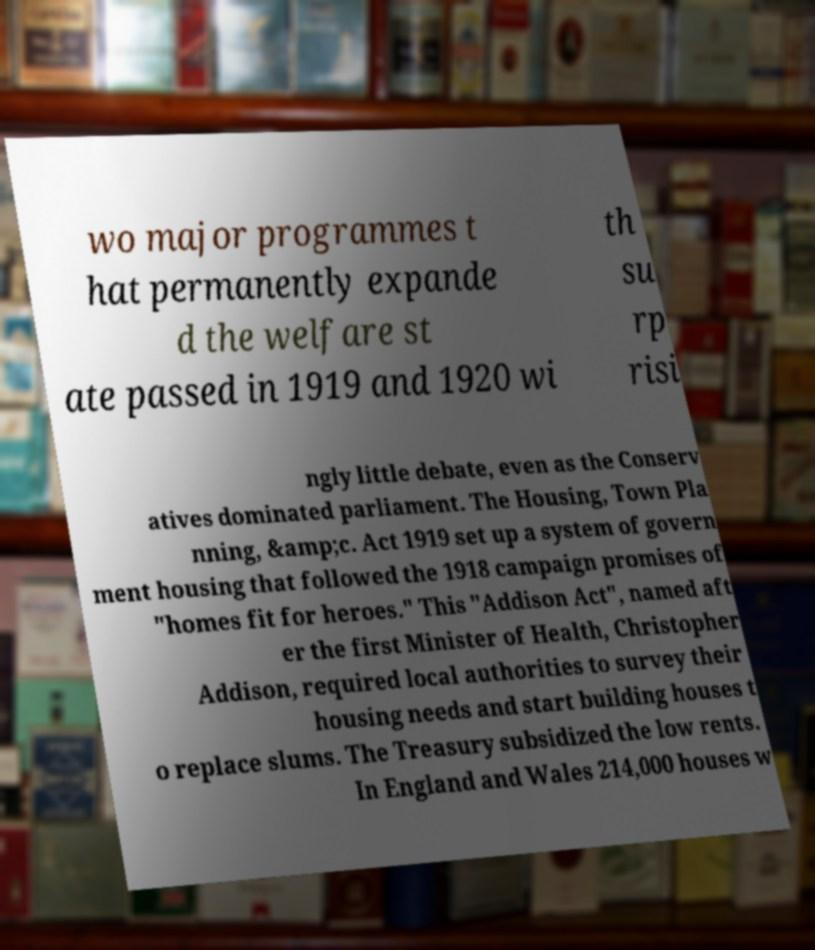There's text embedded in this image that I need extracted. Can you transcribe it verbatim? wo major programmes t hat permanently expande d the welfare st ate passed in 1919 and 1920 wi th su rp risi ngly little debate, even as the Conserv atives dominated parliament. The Housing, Town Pla nning, &amp;c. Act 1919 set up a system of govern ment housing that followed the 1918 campaign promises of "homes fit for heroes." This "Addison Act", named aft er the first Minister of Health, Christopher Addison, required local authorities to survey their housing needs and start building houses t o replace slums. The Treasury subsidized the low rents. In England and Wales 214,000 houses w 